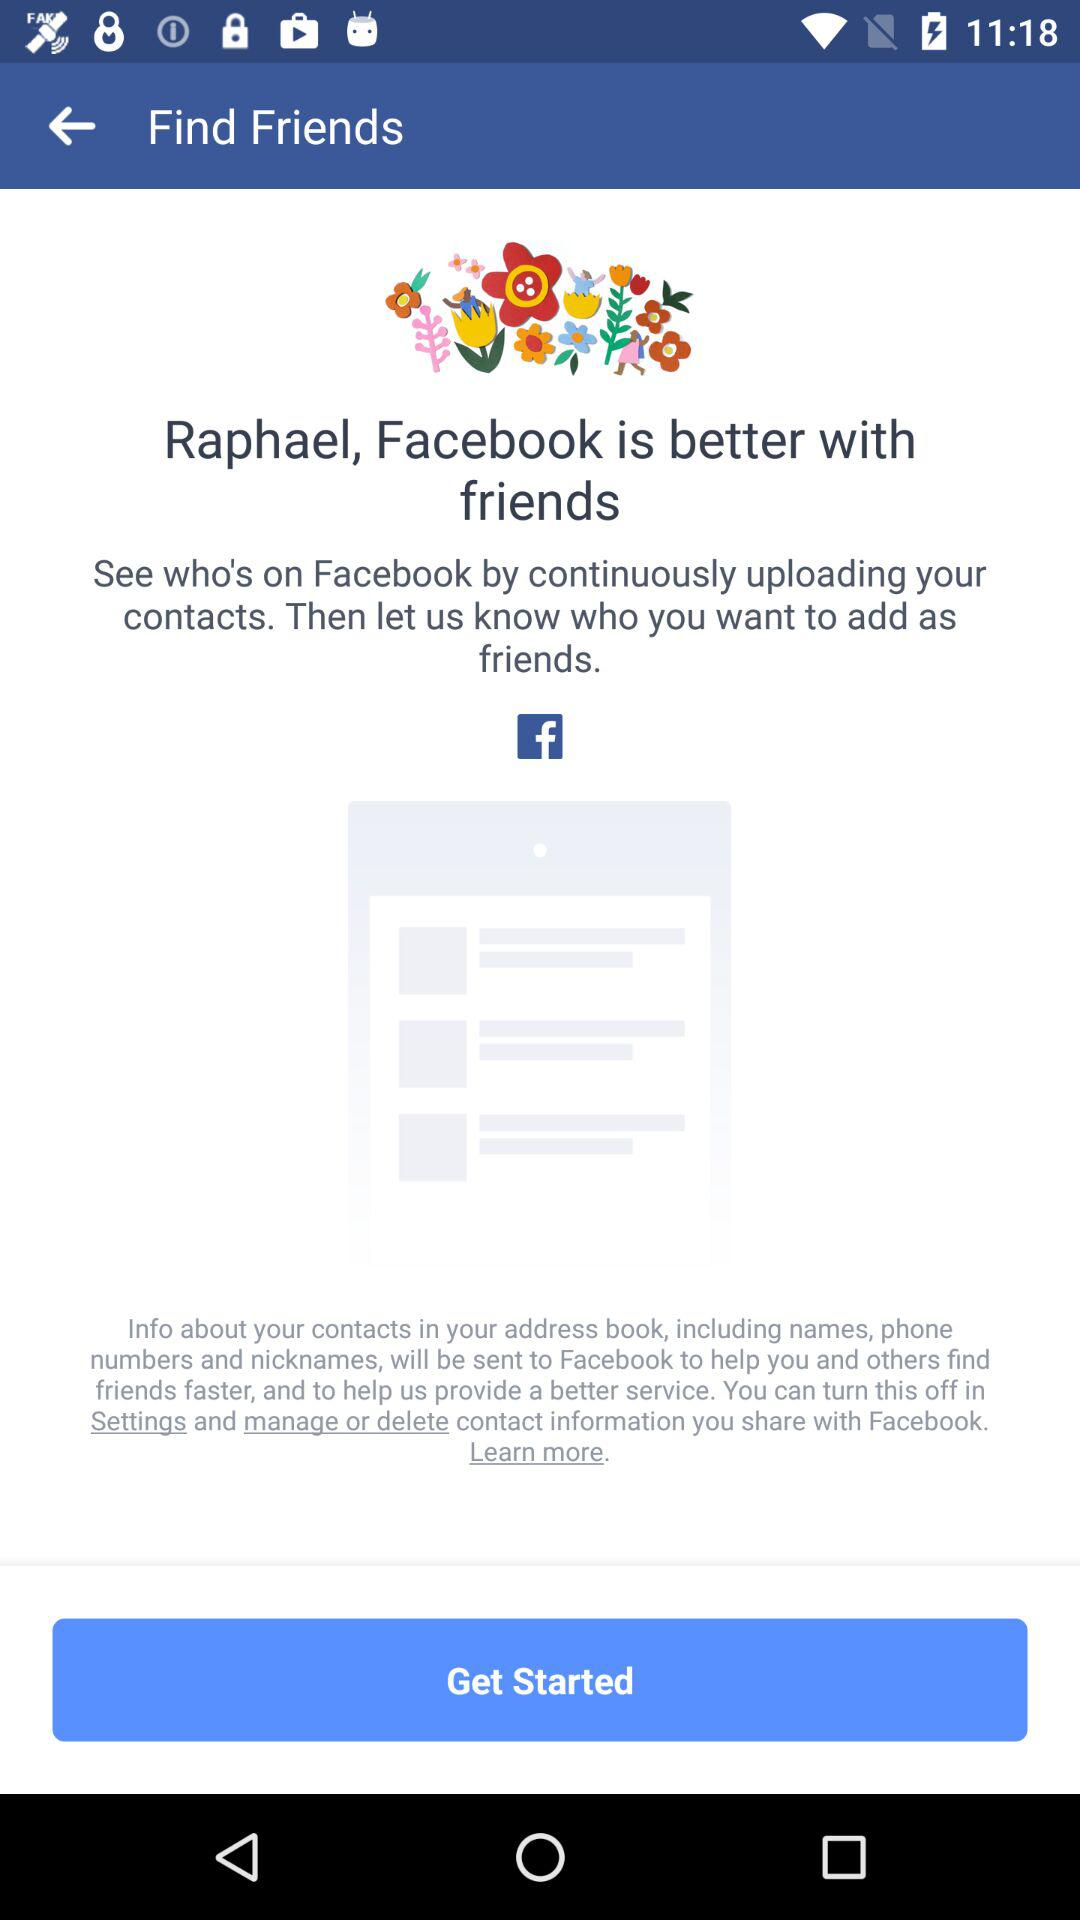Where can we find friends? You can find friends on "Facebook". 